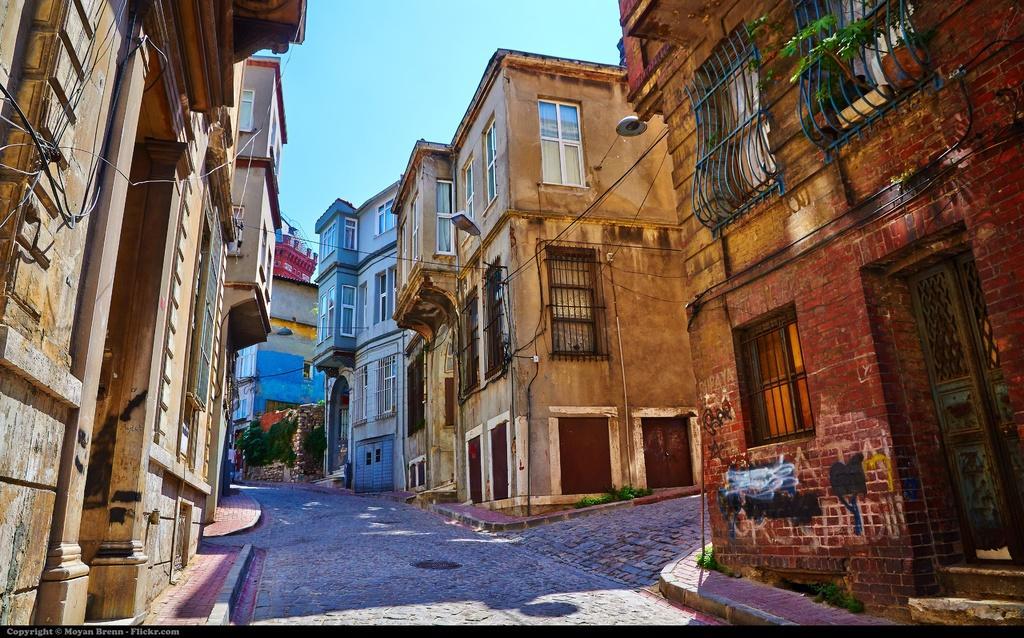Could you give a brief overview of what you see in this image? In the center of the image we can see road. On the right and left side of the image we can see buildings. In the background there is sky. 